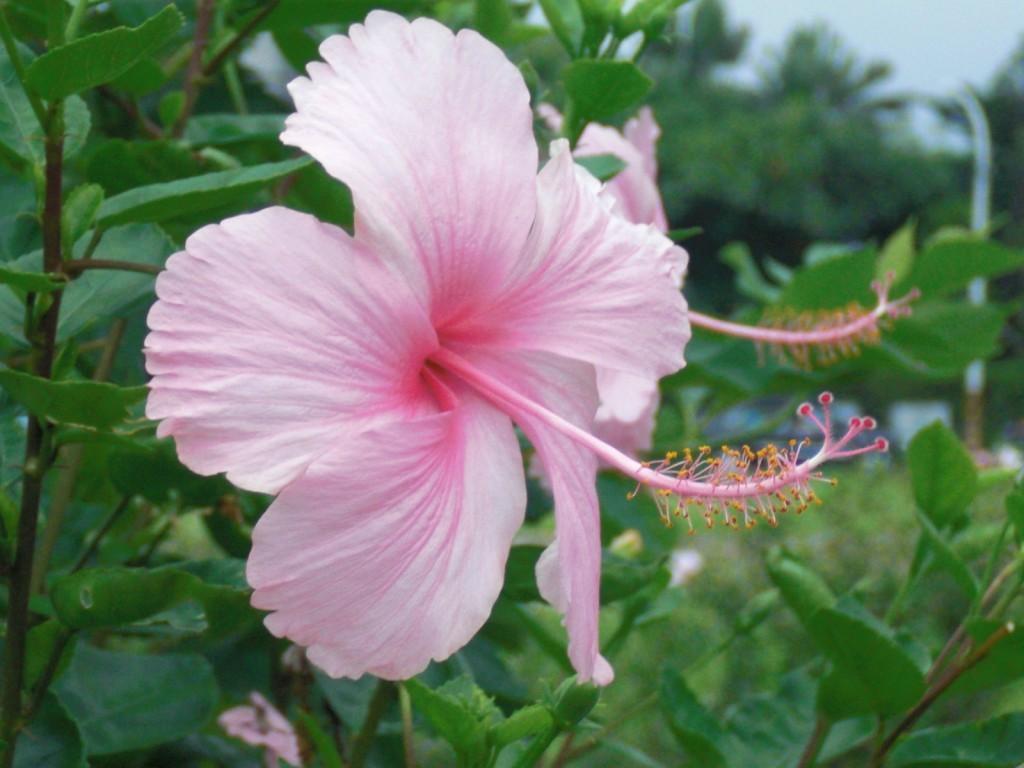In one or two sentences, can you explain what this image depicts? In this image I can see a flower. In the background I can see few trees. 